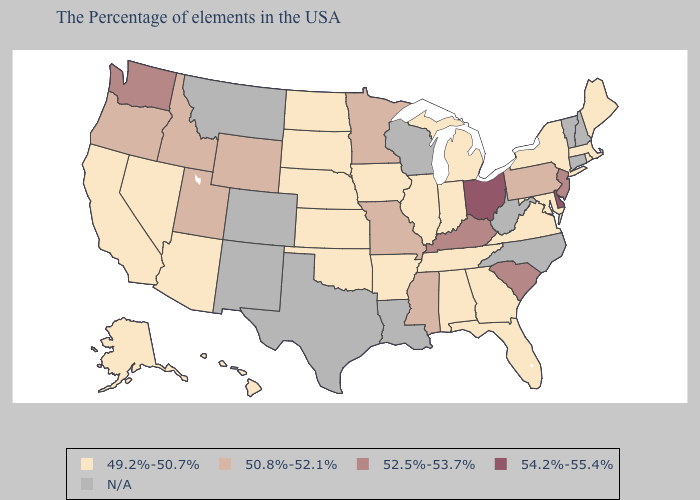Is the legend a continuous bar?
Keep it brief. No. Does Delaware have the highest value in the USA?
Quick response, please. Yes. Is the legend a continuous bar?
Keep it brief. No. Does South Carolina have the lowest value in the South?
Answer briefly. No. What is the lowest value in the MidWest?
Keep it brief. 49.2%-50.7%. What is the lowest value in states that border New York?
Concise answer only. 49.2%-50.7%. Does Alabama have the highest value in the USA?
Write a very short answer. No. Name the states that have a value in the range 49.2%-50.7%?
Quick response, please. Maine, Massachusetts, Rhode Island, New York, Maryland, Virginia, Florida, Georgia, Michigan, Indiana, Alabama, Tennessee, Illinois, Arkansas, Iowa, Kansas, Nebraska, Oklahoma, South Dakota, North Dakota, Arizona, Nevada, California, Alaska, Hawaii. Among the states that border Tennessee , which have the lowest value?
Keep it brief. Virginia, Georgia, Alabama, Arkansas. What is the value of Missouri?
Quick response, please. 50.8%-52.1%. Does Kansas have the highest value in the USA?
Concise answer only. No. Name the states that have a value in the range N/A?
Be succinct. New Hampshire, Vermont, Connecticut, North Carolina, West Virginia, Wisconsin, Louisiana, Texas, Colorado, New Mexico, Montana. Does the first symbol in the legend represent the smallest category?
Answer briefly. Yes. 